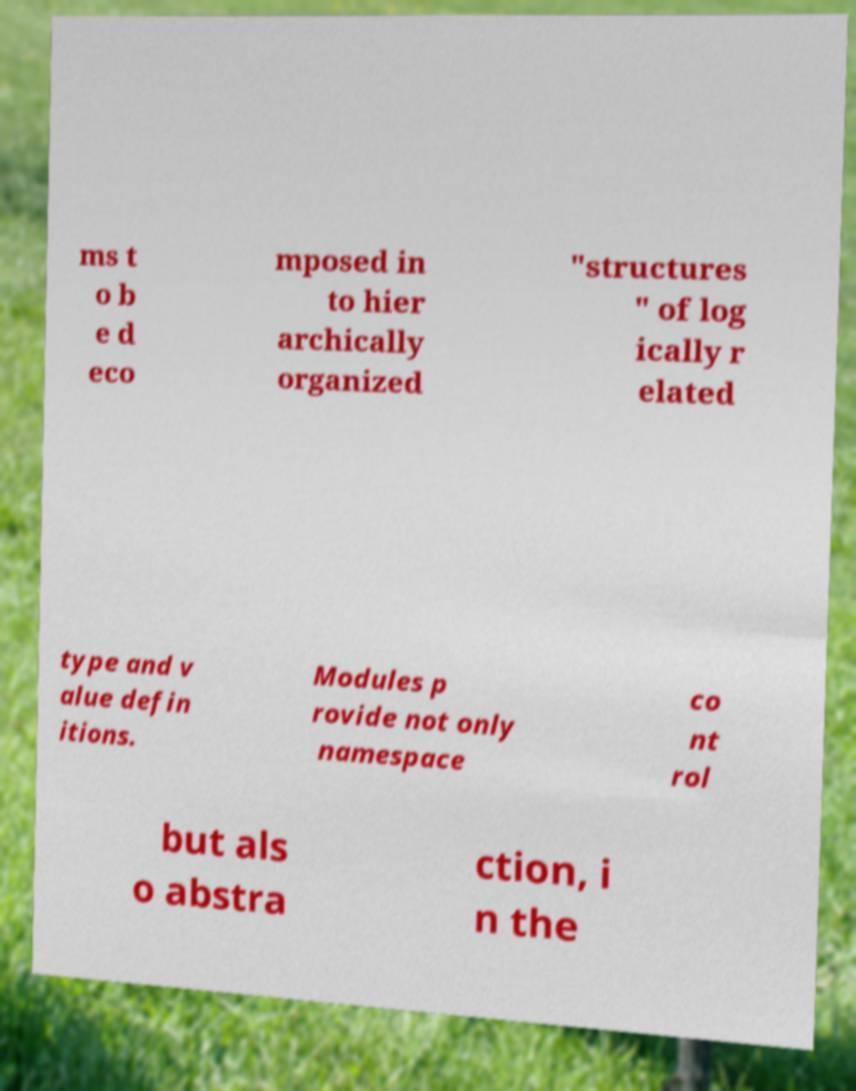Could you extract and type out the text from this image? ms t o b e d eco mposed in to hier archically organized "structures " of log ically r elated type and v alue defin itions. Modules p rovide not only namespace co nt rol but als o abstra ction, i n the 